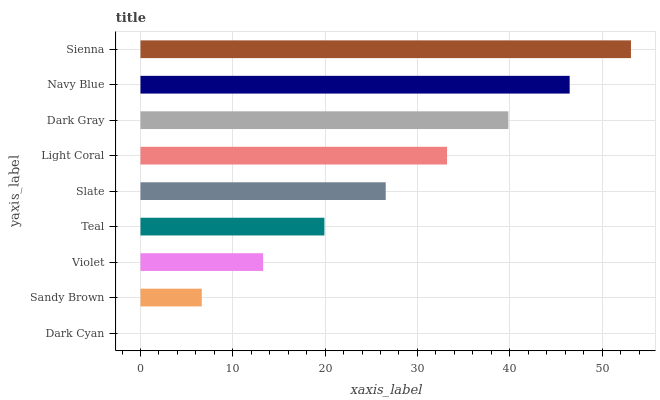Is Dark Cyan the minimum?
Answer yes or no. Yes. Is Sienna the maximum?
Answer yes or no. Yes. Is Sandy Brown the minimum?
Answer yes or no. No. Is Sandy Brown the maximum?
Answer yes or no. No. Is Sandy Brown greater than Dark Cyan?
Answer yes or no. Yes. Is Dark Cyan less than Sandy Brown?
Answer yes or no. Yes. Is Dark Cyan greater than Sandy Brown?
Answer yes or no. No. Is Sandy Brown less than Dark Cyan?
Answer yes or no. No. Is Slate the high median?
Answer yes or no. Yes. Is Slate the low median?
Answer yes or no. Yes. Is Dark Cyan the high median?
Answer yes or no. No. Is Sandy Brown the low median?
Answer yes or no. No. 